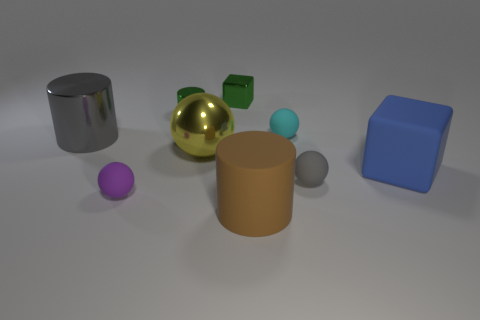Are any green objects visible? Yes, there is one small green cube visible among the objects. 